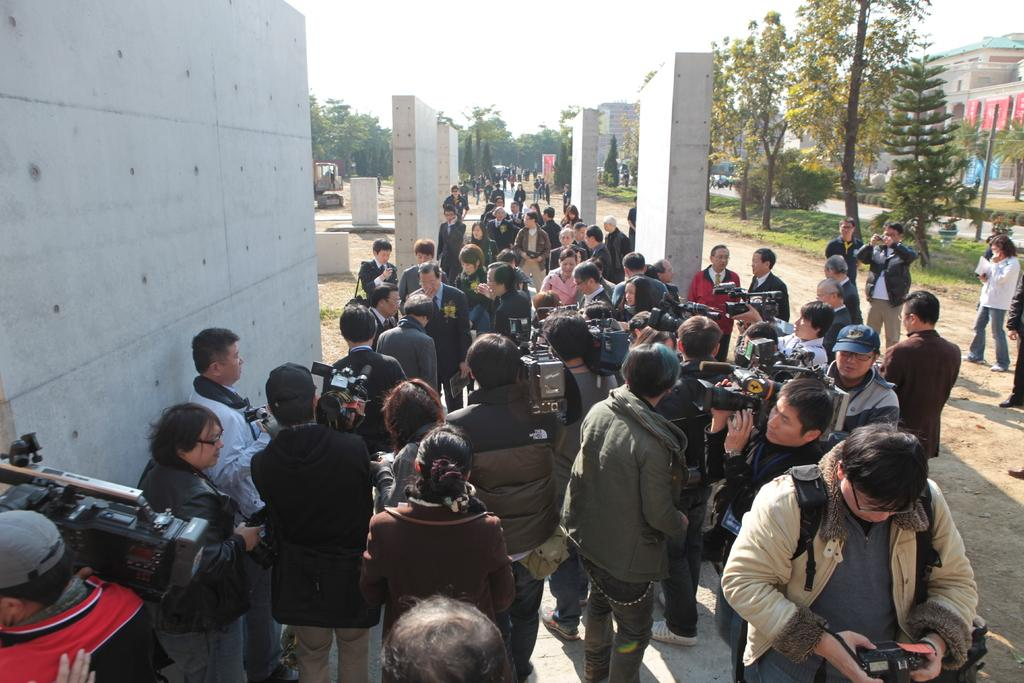What is the main subject of the image? The main subject of the image is a crowd. What are some people in the crowd doing? Some people in the crowd are holding video cameras. What accessories are some people wearing? Some people in the crowd are wearing caps. What type of structures can be seen in the image? There are walls visible in the image. What type of natural environment is present in the image? There are many trees in the image. What is visible in the background of the image? The sky is visible in the background of the image. How many farm animals can be seen in the image? There are no farm animals present in the image; it features a crowd of people. What type of creature is shown interacting with the people in the image? There is no creature shown interacting with the people in the image; only the crowd and their actions are present. 